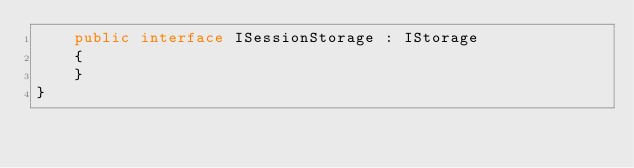<code> <loc_0><loc_0><loc_500><loc_500><_C#_>    public interface ISessionStorage : IStorage
    {
    }
}</code> 